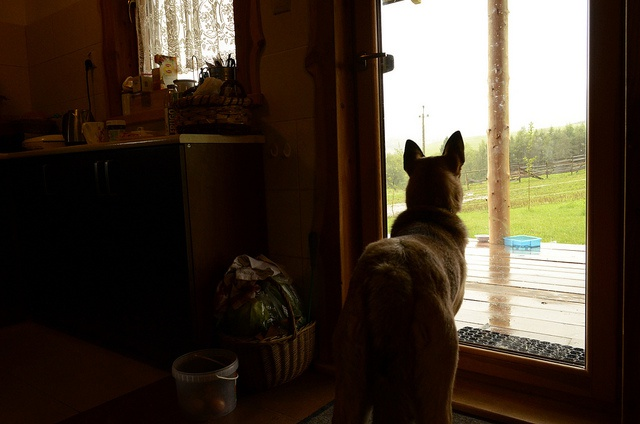Describe the objects in this image and their specific colors. I can see dog in maroon, black, and gray tones, potted plant in maroon, black, white, and gray tones, and cup in black and maroon tones in this image. 